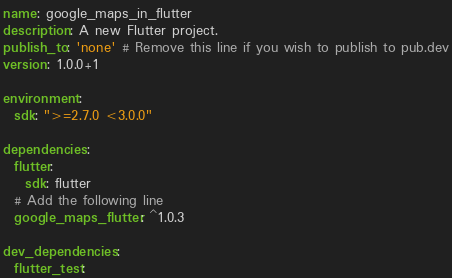<code> <loc_0><loc_0><loc_500><loc_500><_YAML_>name: google_maps_in_flutter
description: A new Flutter project.
publish_to: 'none' # Remove this line if you wish to publish to pub.dev
version: 1.0.0+1

environment:
  sdk: ">=2.7.0 <3.0.0"

dependencies:
  flutter:
    sdk: flutter
  # Add the following line
  google_maps_flutter: ^1.0.3

dev_dependencies:
  flutter_test:</code> 